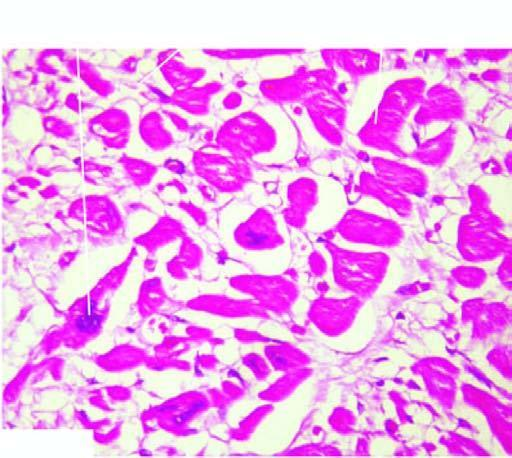what are thick with abundance of eosinophilic cytoplasm?
Answer the question using a single word or phrase. The myocardial muscle fibres cytoplasm 